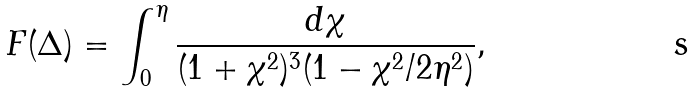Convert formula to latex. <formula><loc_0><loc_0><loc_500><loc_500>F ( \Delta ) = \int _ { 0 } ^ { \eta } \frac { d \chi } { ( 1 + \chi ^ { 2 } ) ^ { 3 } ( 1 - \chi ^ { 2 } / 2 \eta ^ { 2 } ) } ,</formula> 